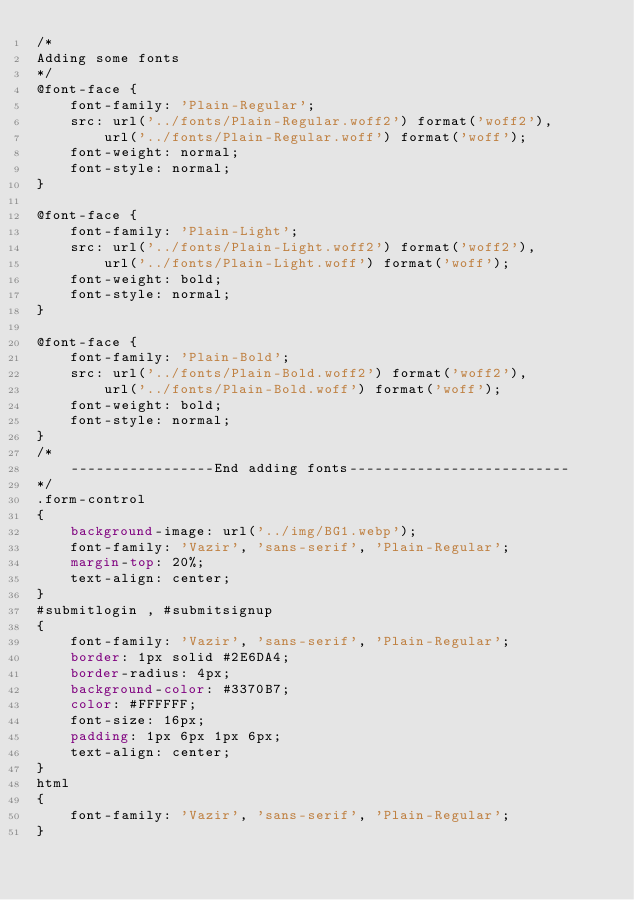Convert code to text. <code><loc_0><loc_0><loc_500><loc_500><_CSS_>/*
Adding some fonts
*/
@font-face {
	font-family: 'Plain-Regular';
	src: url('../fonts/Plain-Regular.woff2') format('woff2'),
		url('../fonts/Plain-Regular.woff') format('woff');
	font-weight: normal;
	font-style: normal;
}

@font-face {
	font-family: 'Plain-Light';
	src: url('../fonts/Plain-Light.woff2') format('woff2'),
		url('../fonts/Plain-Light.woff') format('woff');
	font-weight: bold;
	font-style: normal;
}

@font-face {
	font-family: 'Plain-Bold';
	src: url('../fonts/Plain-Bold.woff2') format('woff2'),
		url('../fonts/Plain-Bold.woff') format('woff');
	font-weight: bold;
	font-style: normal;
}
/*
	-----------------End adding fonts--------------------------
*/
.form-control
{
	background-image: url('../img/BG1.webp');
	font-family: 'Vazir', 'sans-serif', 'Plain-Regular';
	margin-top: 20%;
    text-align: center;
}
#submitlogin , #submitsignup
{
    font-family: 'Vazir', 'sans-serif', 'Plain-Regular';
    border: 1px solid #2E6DA4;
    border-radius: 4px;
    background-color: #3370B7;
    color: #FFFFFF;
    font-size: 16px;
    padding: 1px 6px 1px 6px;
    text-align: center;
}
html
{
	font-family: 'Vazir', 'sans-serif', 'Plain-Regular';
}</code> 